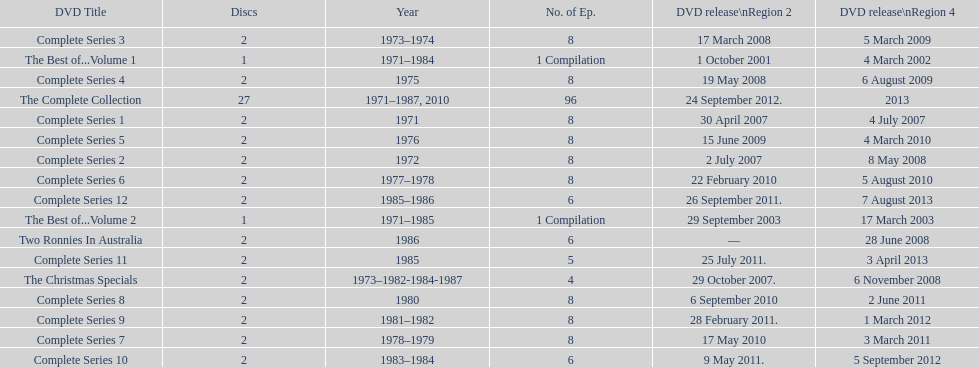What appears right after the entire series 11? Complete Series 12. 